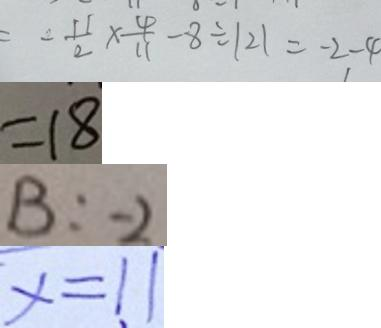<formula> <loc_0><loc_0><loc_500><loc_500>= - \frac { 1 1 } { 2 } \times \frac { 4 } { 1 1 } - 8 \div \vert 2 \vert = - 2 - 4 
 = 1 8 
 B : - 2 
 x = 1 1</formula> 